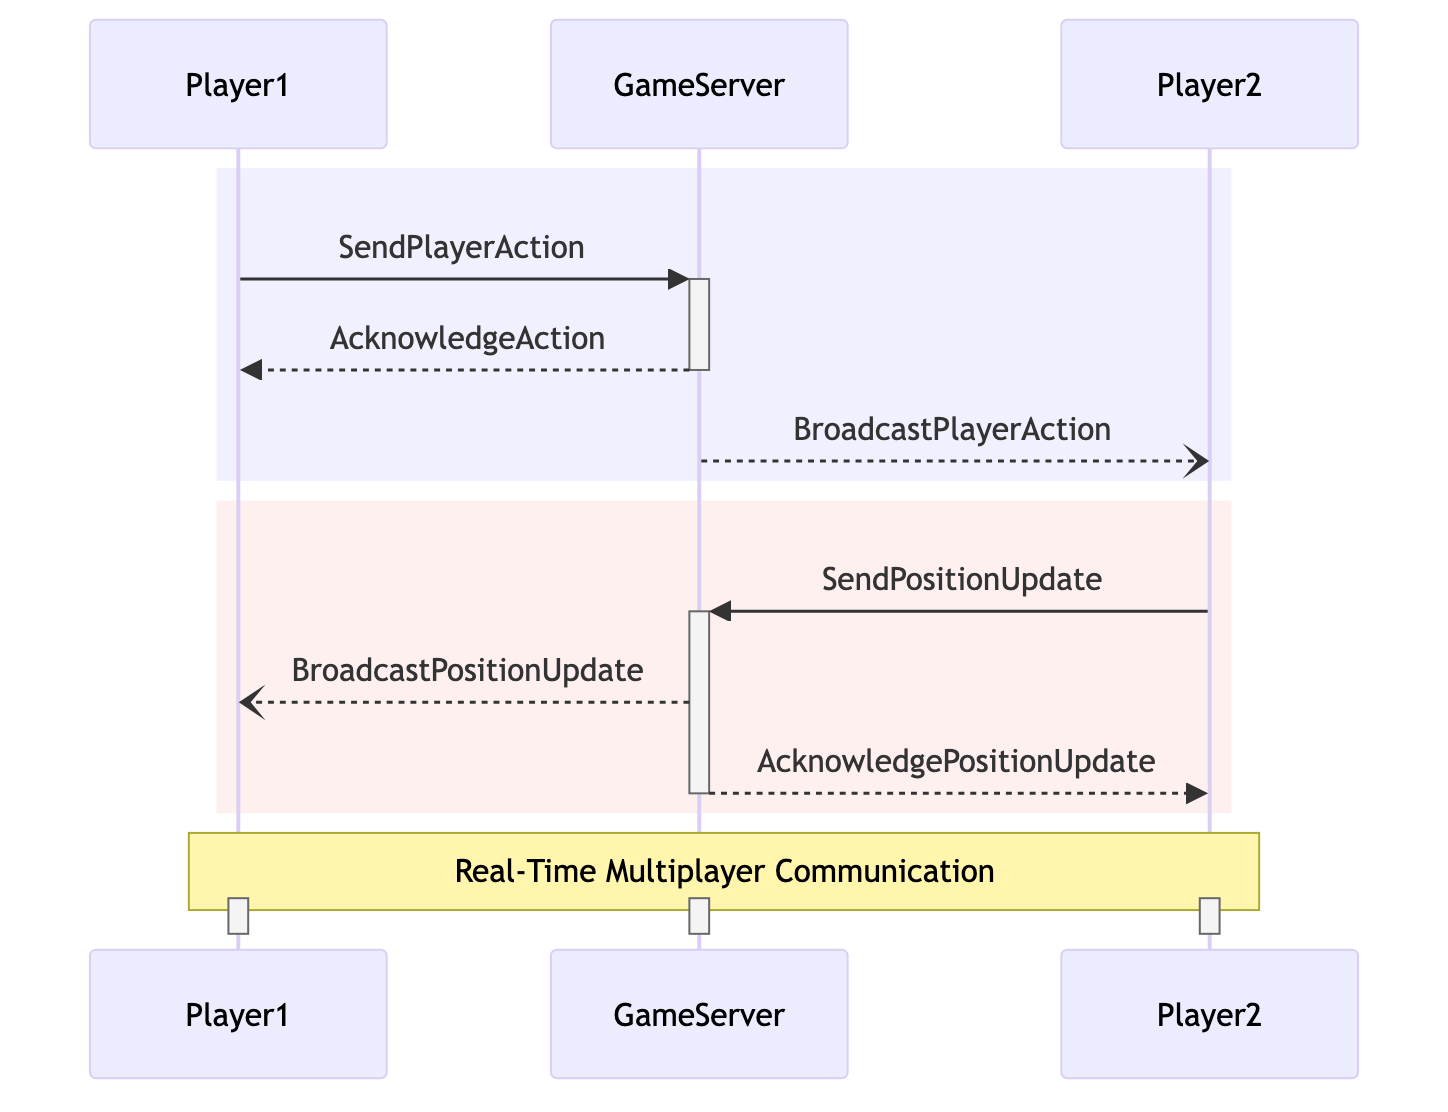What actors are involved in this diagram? The diagram includes three actors: Player1, Player2, and GameServer.
Answer: Player1, Player2, GameServer How many messages are sent from Player1 to the GameServer? There are two messages sent from Player1 to GameServer: "SendPlayerAction" and "AcknowledgeAction."
Answer: 2 What type of message is "BroadcastPlayerAction"? The type of "BroadcastPlayerAction" is asynchronous, as indicated in the diagram.
Answer: Asynchronous Which actor is responsible for sending "AcknowledgePositionUpdate"? The GameServer is responsible for sending "AcknowledgePositionUpdate" to Player2.
Answer: GameServer What happens after Player1 sends "SendPlayerAction"? After Player1 sends "SendPlayerAction," the GameServer sends an "AcknowledgeAction" back to Player1.
Answer: AcknowledgeAction What is the sequence of actions when Player2 sends a position update? The sequence is: Player2 sends "SendPositionUpdate" to GameServer, then GameServer broadcasts the position update to Player1, and finally sends "AcknowledgePositionUpdate" to Player2.
Answer: SendPositionUpdate, BroadcastPositionUpdate, AcknowledgePositionUpdate How many total asynchronous messages are depicted in the diagram? There are two asynchronous messages: "BroadcastPlayerAction" and "BroadcastPositionUpdate."
Answer: 2 What message does Player2 send to GameServer? Player2 sends "SendPositionUpdate" to GameServer.
Answer: SendPositionUpdate What is the communication pattern between GameServer and Player1 for the first action? The pattern starts with Player1 sending "SendPlayerAction" to GameServer, followed by the GameServer sending "AcknowledgeAction" back to Player1.
Answer: SendPlayerAction, AcknowledgeAction 